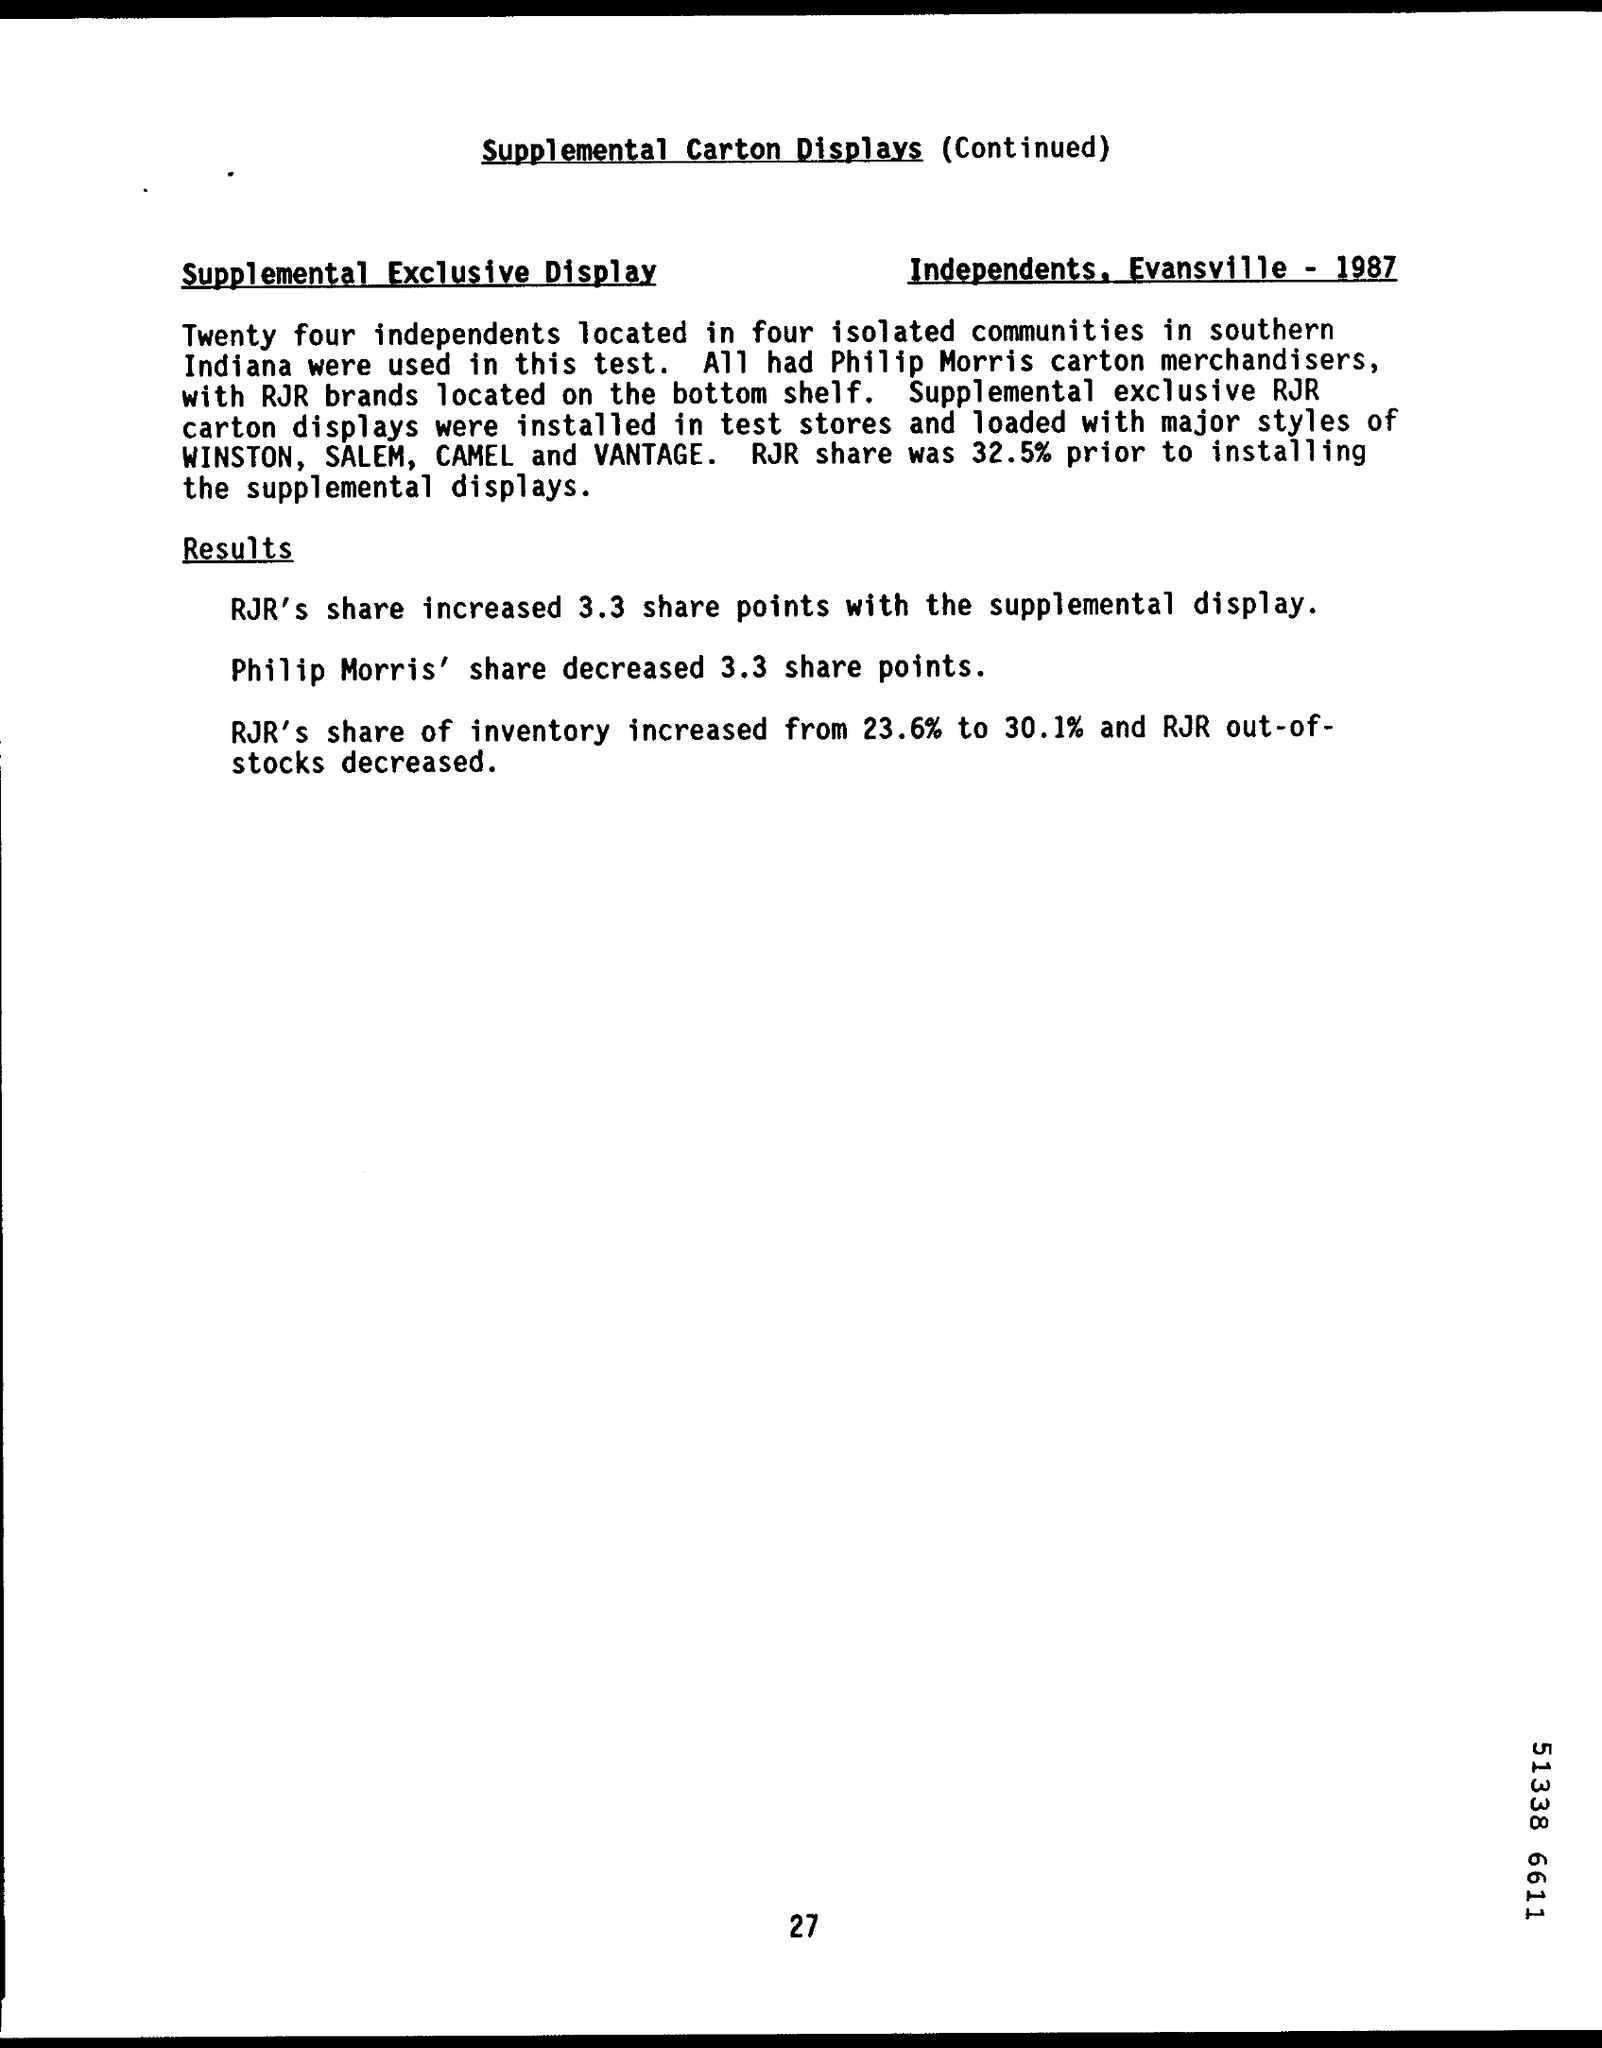Specify some key components in this picture. A total of 24 independent samples were used in this test. Prior to installing the supplemental displays, the RJR share was 32.5%. Philip Morris' share decreased by 3.3%. RJR's share increased by 3.3 share points with the supplemental display. 